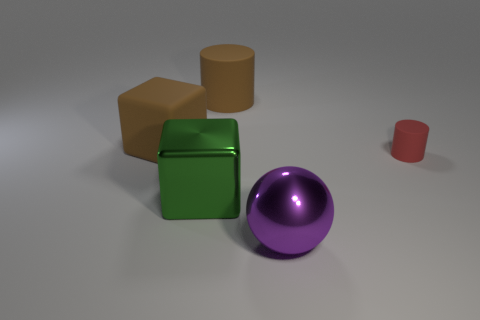Can you tell me more about the different objects' materials in the image? Certainly! The objects in the image appear to have different kinds of surface textures. The green cube has a reflective and shiny surface, suggesting it might be made of a polished material like plastic or glass. The brown cube and the tan cylinder have more matte finishes, indicating they could be made of clay or an unpolished stone. Lastly, the purple sphere and the small red cylinder seem to have a slight gloss, suggesting a material like painted wood or plastic. 